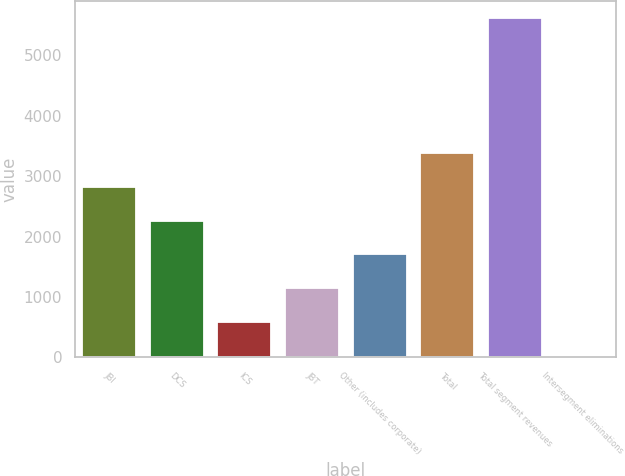Convert chart. <chart><loc_0><loc_0><loc_500><loc_500><bar_chart><fcel>JBI<fcel>DCS<fcel>ICS<fcel>JBT<fcel>Other (includes corporate)<fcel>Total<fcel>Total segment revenues<fcel>Intersegment eliminations<nl><fcel>2822.5<fcel>2264<fcel>588.5<fcel>1147<fcel>1705.5<fcel>3381<fcel>5615<fcel>30<nl></chart> 